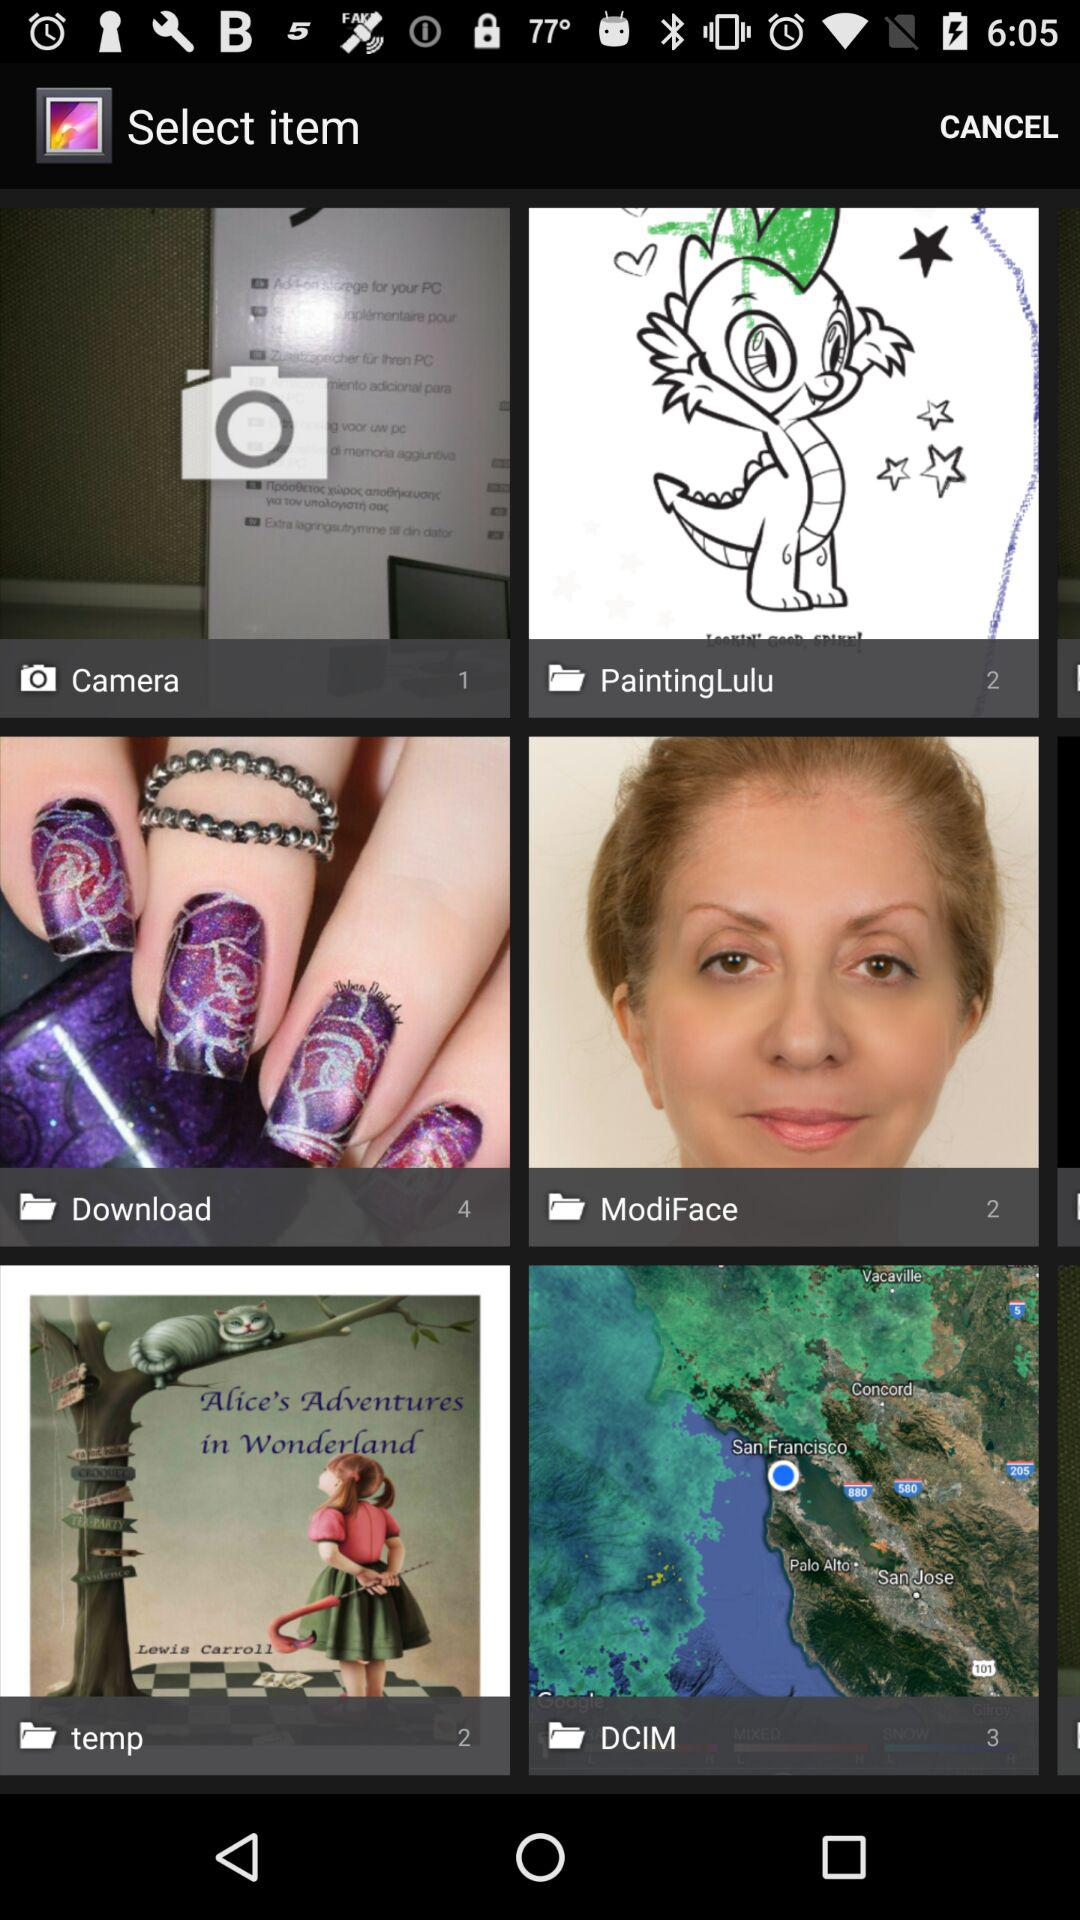How many images are contained in "temp" folder? There are 2 images in "temp" folder. 